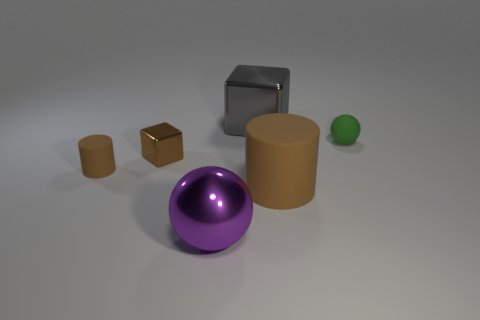Are there any other things that have the same material as the green ball?
Your answer should be very brief. Yes. What color is the tiny thing that is the same material as the gray block?
Make the answer very short. Brown. There is a big shiny thing behind the rubber sphere; does it have the same shape as the small matte thing that is on the left side of the tiny sphere?
Ensure brevity in your answer.  No. There is a brown shiny object that is the same size as the green sphere; what shape is it?
Offer a terse response. Cube. Are there the same number of small brown objects on the right side of the large metallic sphere and tiny green things left of the small shiny object?
Your answer should be very brief. Yes. Are there any other things that have the same shape as the small brown metal object?
Give a very brief answer. Yes. Is the material of the ball to the right of the big brown cylinder the same as the large purple ball?
Your response must be concise. No. There is a brown object that is the same size as the gray metallic object; what is it made of?
Offer a very short reply. Rubber. There is a gray thing; is it the same size as the sphere in front of the small green rubber sphere?
Your answer should be compact. Yes. Is the number of purple metallic things that are behind the tiny brown metal block less than the number of small matte spheres behind the big brown thing?
Offer a terse response. Yes. 